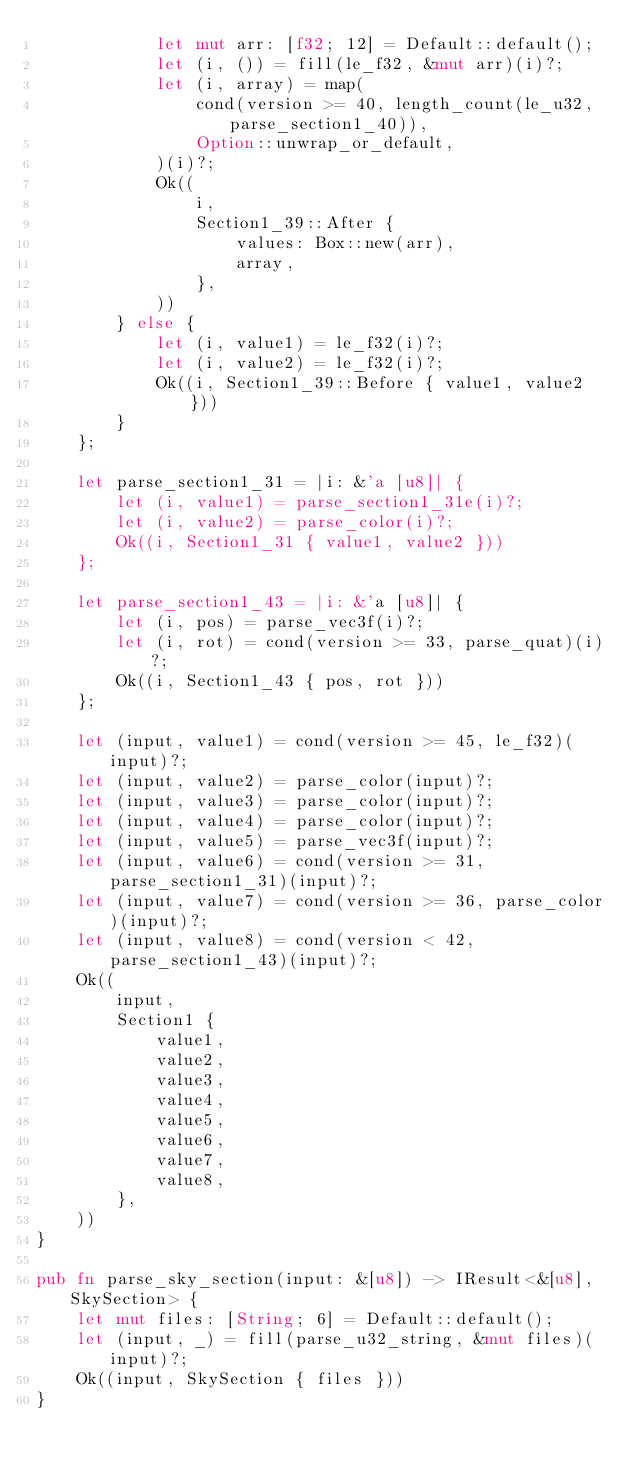Convert code to text. <code><loc_0><loc_0><loc_500><loc_500><_Rust_>            let mut arr: [f32; 12] = Default::default();
            let (i, ()) = fill(le_f32, &mut arr)(i)?;
            let (i, array) = map(
                cond(version >= 40, length_count(le_u32, parse_section1_40)),
                Option::unwrap_or_default,
            )(i)?;
            Ok((
                i,
                Section1_39::After {
                    values: Box::new(arr),
                    array,
                },
            ))
        } else {
            let (i, value1) = le_f32(i)?;
            let (i, value2) = le_f32(i)?;
            Ok((i, Section1_39::Before { value1, value2 }))
        }
    };

    let parse_section1_31 = |i: &'a [u8]| {
        let (i, value1) = parse_section1_31e(i)?;
        let (i, value2) = parse_color(i)?;
        Ok((i, Section1_31 { value1, value2 }))
    };

    let parse_section1_43 = |i: &'a [u8]| {
        let (i, pos) = parse_vec3f(i)?;
        let (i, rot) = cond(version >= 33, parse_quat)(i)?;
        Ok((i, Section1_43 { pos, rot }))
    };

    let (input, value1) = cond(version >= 45, le_f32)(input)?;
    let (input, value2) = parse_color(input)?;
    let (input, value3) = parse_color(input)?;
    let (input, value4) = parse_color(input)?;
    let (input, value5) = parse_vec3f(input)?;
    let (input, value6) = cond(version >= 31, parse_section1_31)(input)?;
    let (input, value7) = cond(version >= 36, parse_color)(input)?;
    let (input, value8) = cond(version < 42, parse_section1_43)(input)?;
    Ok((
        input,
        Section1 {
            value1,
            value2,
            value3,
            value4,
            value5,
            value6,
            value7,
            value8,
        },
    ))
}

pub fn parse_sky_section(input: &[u8]) -> IResult<&[u8], SkySection> {
    let mut files: [String; 6] = Default::default();
    let (input, _) = fill(parse_u32_string, &mut files)(input)?;
    Ok((input, SkySection { files }))
}
</code> 